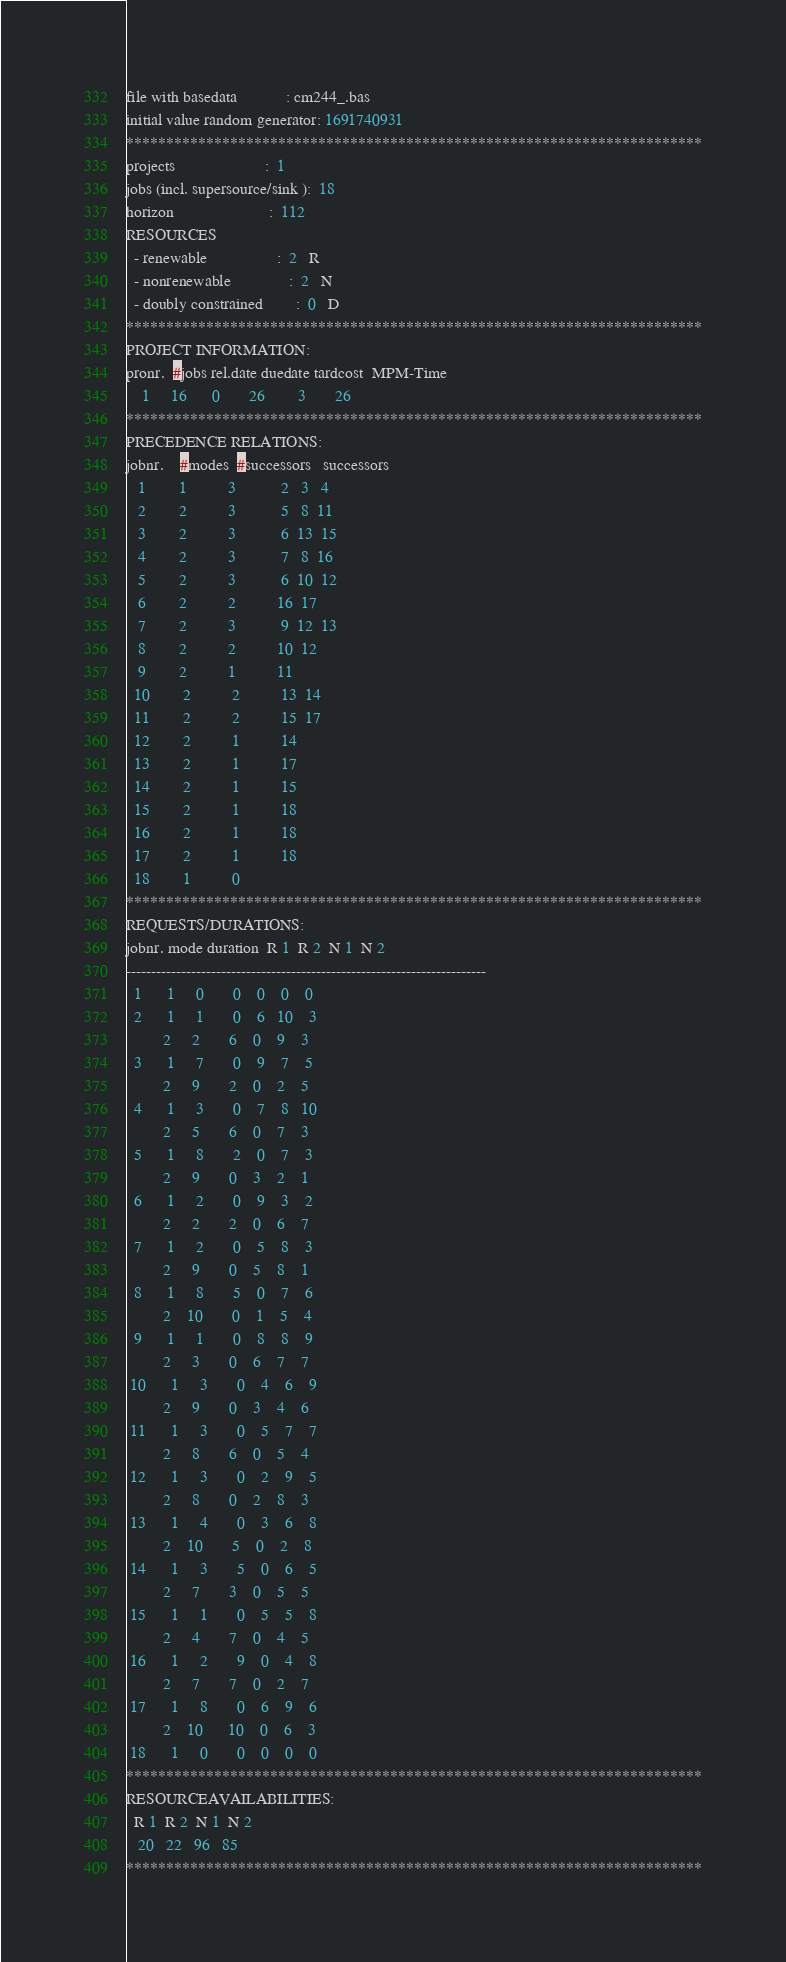<code> <loc_0><loc_0><loc_500><loc_500><_ObjectiveC_>file with basedata            : cm244_.bas
initial value random generator: 1691740931
************************************************************************
projects                      :  1
jobs (incl. supersource/sink ):  18
horizon                       :  112
RESOURCES
  - renewable                 :  2   R
  - nonrenewable              :  2   N
  - doubly constrained        :  0   D
************************************************************************
PROJECT INFORMATION:
pronr.  #jobs rel.date duedate tardcost  MPM-Time
    1     16      0       26        3       26
************************************************************************
PRECEDENCE RELATIONS:
jobnr.    #modes  #successors   successors
   1        1          3           2   3   4
   2        2          3           5   8  11
   3        2          3           6  13  15
   4        2          3           7   8  16
   5        2          3           6  10  12
   6        2          2          16  17
   7        2          3           9  12  13
   8        2          2          10  12
   9        2          1          11
  10        2          2          13  14
  11        2          2          15  17
  12        2          1          14
  13        2          1          17
  14        2          1          15
  15        2          1          18
  16        2          1          18
  17        2          1          18
  18        1          0        
************************************************************************
REQUESTS/DURATIONS:
jobnr. mode duration  R 1  R 2  N 1  N 2
------------------------------------------------------------------------
  1      1     0       0    0    0    0
  2      1     1       0    6   10    3
         2     2       6    0    9    3
  3      1     7       0    9    7    5
         2     9       2    0    2    5
  4      1     3       0    7    8   10
         2     5       6    0    7    3
  5      1     8       2    0    7    3
         2     9       0    3    2    1
  6      1     2       0    9    3    2
         2     2       2    0    6    7
  7      1     2       0    5    8    3
         2     9       0    5    8    1
  8      1     8       5    0    7    6
         2    10       0    1    5    4
  9      1     1       0    8    8    9
         2     3       0    6    7    7
 10      1     3       0    4    6    9
         2     9       0    3    4    6
 11      1     3       0    5    7    7
         2     8       6    0    5    4
 12      1     3       0    2    9    5
         2     8       0    2    8    3
 13      1     4       0    3    6    8
         2    10       5    0    2    8
 14      1     3       5    0    6    5
         2     7       3    0    5    5
 15      1     1       0    5    5    8
         2     4       7    0    4    5
 16      1     2       9    0    4    8
         2     7       7    0    2    7
 17      1     8       0    6    9    6
         2    10      10    0    6    3
 18      1     0       0    0    0    0
************************************************************************
RESOURCEAVAILABILITIES:
  R 1  R 2  N 1  N 2
   20   22   96   85
************************************************************************
</code> 